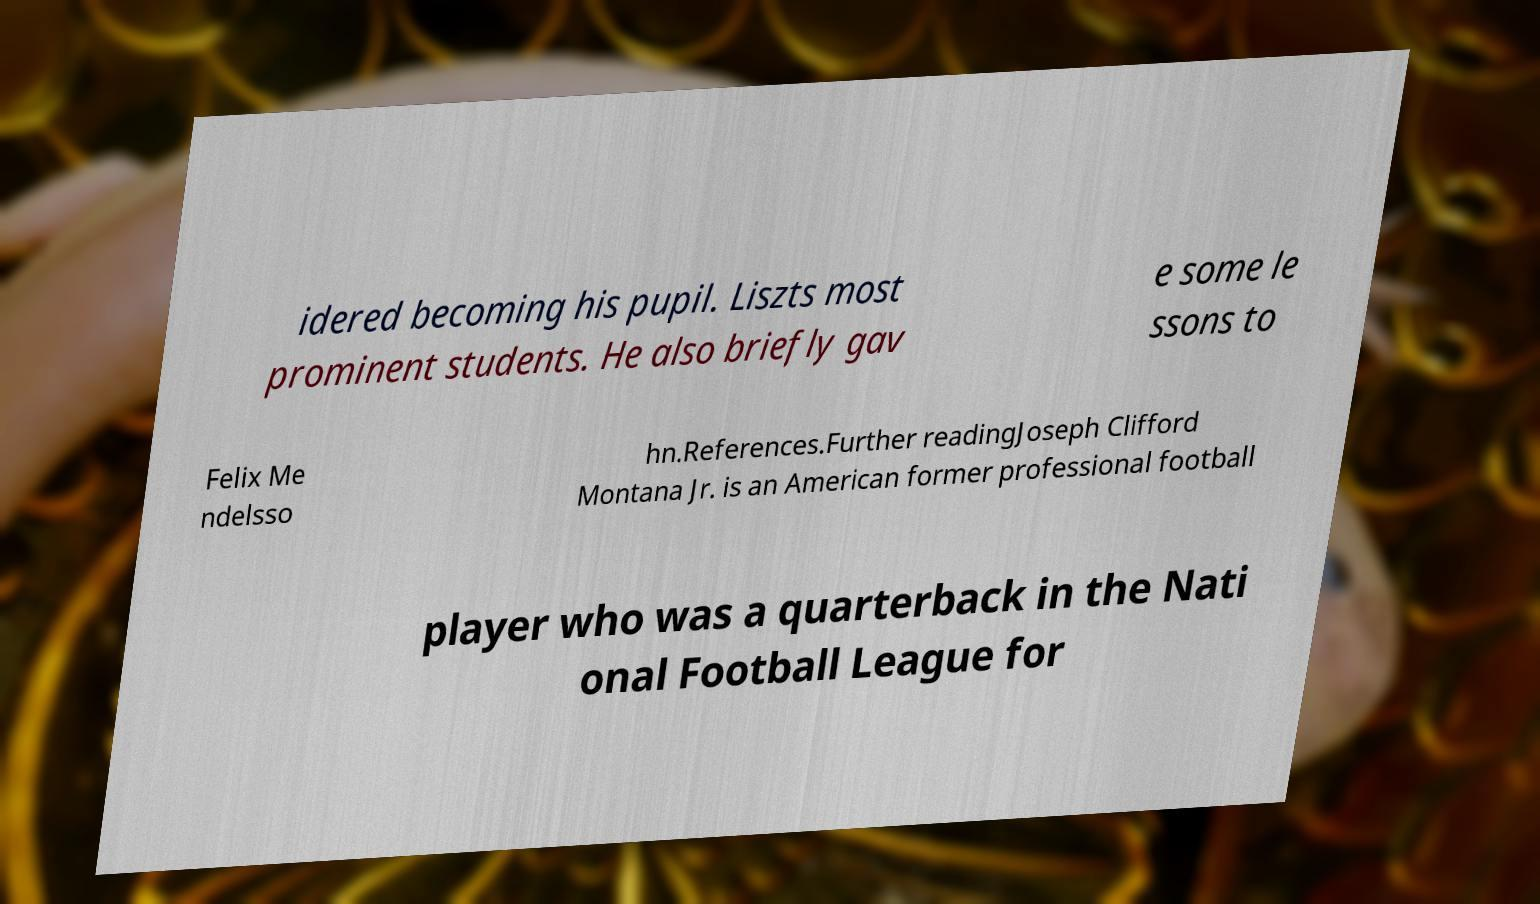Can you accurately transcribe the text from the provided image for me? idered becoming his pupil. Liszts most prominent students. He also briefly gav e some le ssons to Felix Me ndelsso hn.References.Further readingJoseph Clifford Montana Jr. is an American former professional football player who was a quarterback in the Nati onal Football League for 